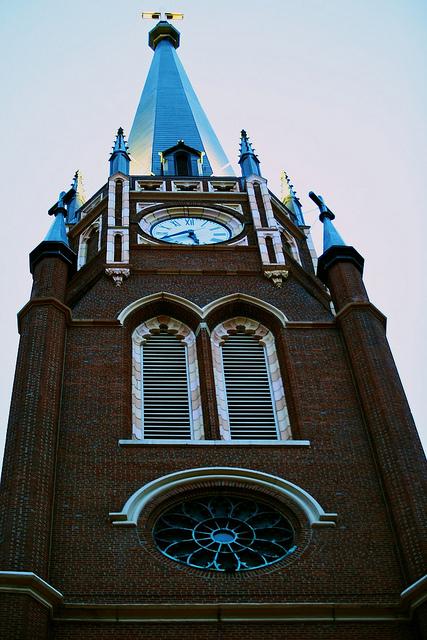What is the material this building is made of?
Quick response, please. Brick. What country is this?
Keep it brief. England. What time is on the clock?
Keep it brief. 5:40. 